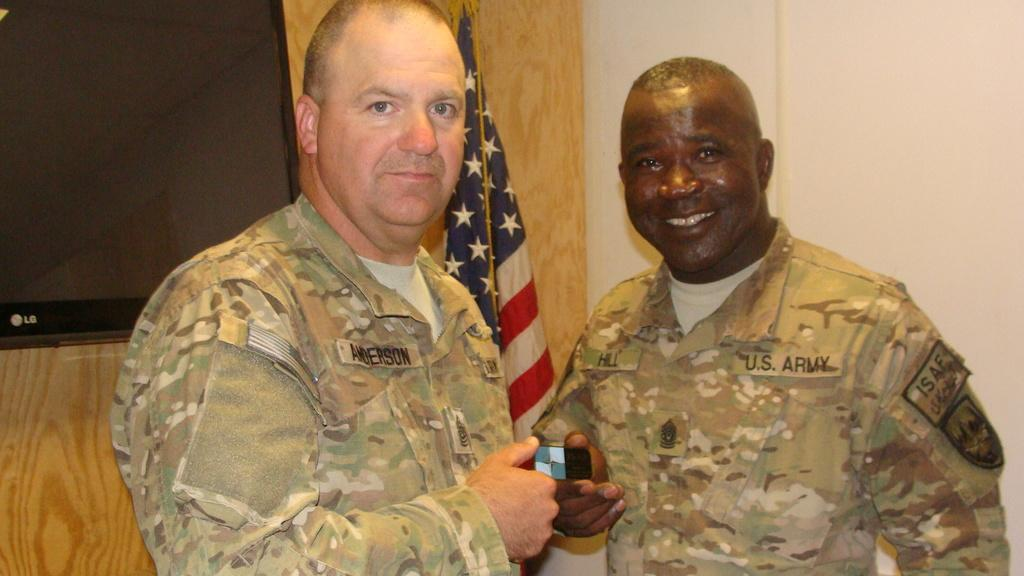How many people are in the image? There are two men in the image. What are the men doing in the image? The men are standing. What can be seen in the background of the image? There is a wall in the background of the image. What is located on the left side of the image? There is a television on the left side of the image. What is visible behind the television? There is a flag visible behind the television. What type of knife is being used by one of the men in the image? There is no knife present in the image. 